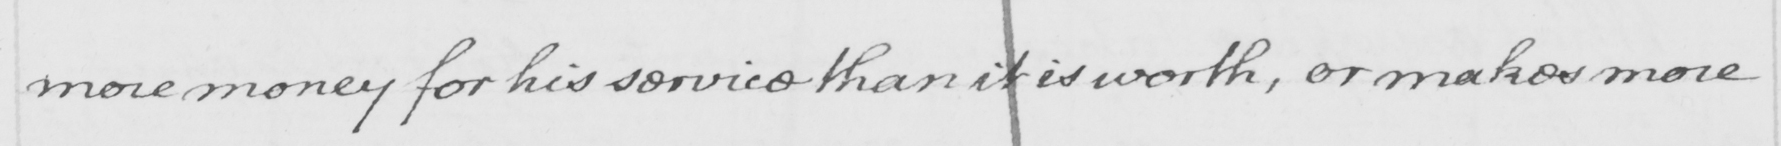What does this handwritten line say? more money for his service than it is worth , or makes more 